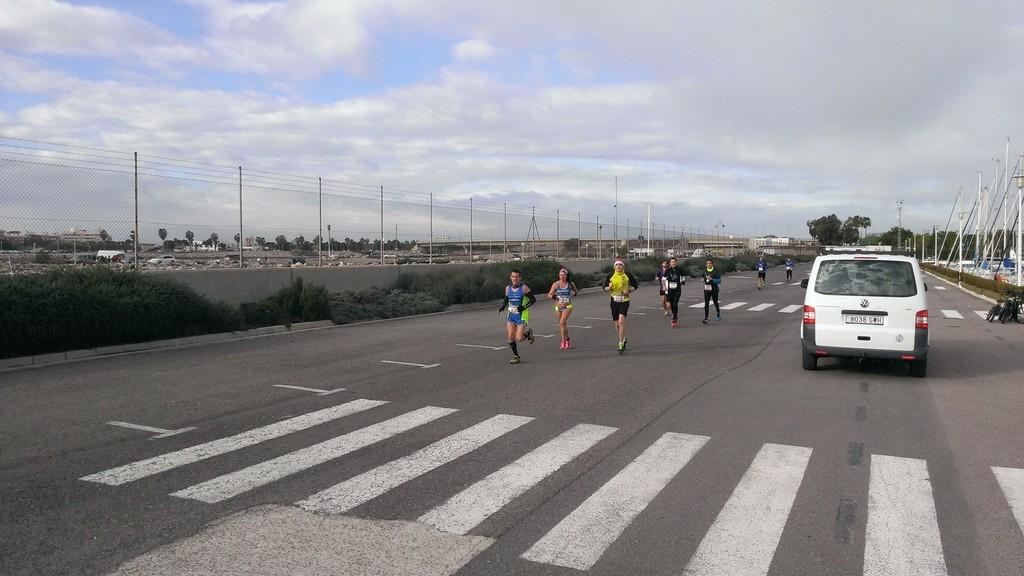What are the people in the image doing? The people in the image are standing on the road. What else can be seen on the road? There is a vehicle parked on the road. What can be seen in the background of the image? There are trees visible in the background. What type of vegetation is present on the road? There are plants on the road. What is the taste of the things hanging from the trees in the image? There are no things hanging from the trees in the image, and therefore no taste can be determined. 